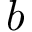<formula> <loc_0><loc_0><loc_500><loc_500>b</formula> 